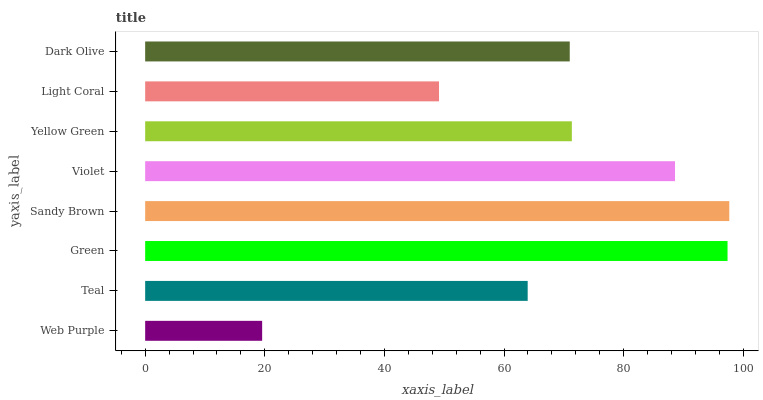Is Web Purple the minimum?
Answer yes or no. Yes. Is Sandy Brown the maximum?
Answer yes or no. Yes. Is Teal the minimum?
Answer yes or no. No. Is Teal the maximum?
Answer yes or no. No. Is Teal greater than Web Purple?
Answer yes or no. Yes. Is Web Purple less than Teal?
Answer yes or no. Yes. Is Web Purple greater than Teal?
Answer yes or no. No. Is Teal less than Web Purple?
Answer yes or no. No. Is Yellow Green the high median?
Answer yes or no. Yes. Is Dark Olive the low median?
Answer yes or no. Yes. Is Green the high median?
Answer yes or no. No. Is Web Purple the low median?
Answer yes or no. No. 